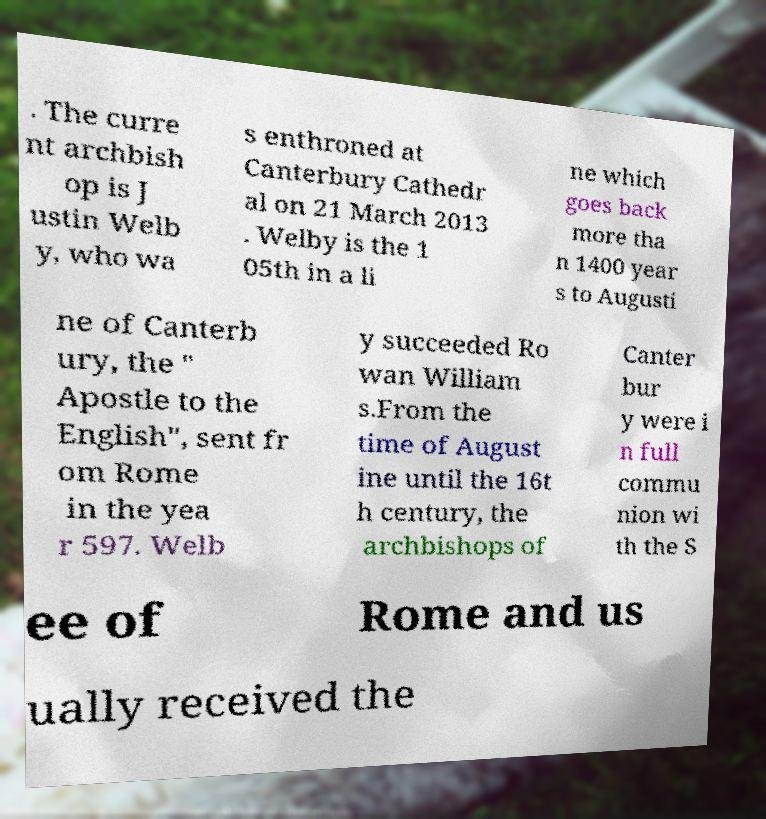Please read and relay the text visible in this image. What does it say? . The curre nt archbish op is J ustin Welb y, who wa s enthroned at Canterbury Cathedr al on 21 March 2013 . Welby is the 1 05th in a li ne which goes back more tha n 1400 year s to Augusti ne of Canterb ury, the " Apostle to the English", sent fr om Rome in the yea r 597. Welb y succeeded Ro wan William s.From the time of August ine until the 16t h century, the archbishops of Canter bur y were i n full commu nion wi th the S ee of Rome and us ually received the 